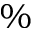Convert formula to latex. <formula><loc_0><loc_0><loc_500><loc_500>\%</formula> 